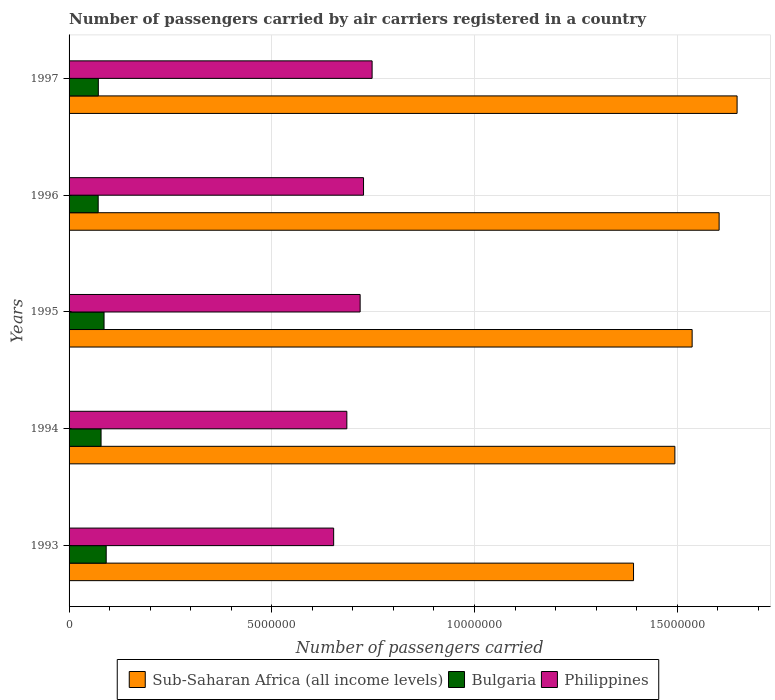How many groups of bars are there?
Provide a succinct answer. 5. Are the number of bars per tick equal to the number of legend labels?
Your answer should be very brief. Yes. How many bars are there on the 2nd tick from the top?
Offer a terse response. 3. What is the number of passengers carried by air carriers in Sub-Saharan Africa (all income levels) in 1997?
Give a very brief answer. 1.65e+07. Across all years, what is the maximum number of passengers carried by air carriers in Bulgaria?
Make the answer very short. 9.16e+05. Across all years, what is the minimum number of passengers carried by air carriers in Philippines?
Your response must be concise. 6.53e+06. What is the total number of passengers carried by air carriers in Bulgaria in the graph?
Offer a very short reply. 4.01e+06. What is the difference between the number of passengers carried by air carriers in Sub-Saharan Africa (all income levels) in 1994 and that in 1997?
Your response must be concise. -1.53e+06. What is the difference between the number of passengers carried by air carriers in Bulgaria in 1993 and the number of passengers carried by air carriers in Philippines in 1997?
Your answer should be compact. -6.56e+06. What is the average number of passengers carried by air carriers in Bulgaria per year?
Ensure brevity in your answer.  8.02e+05. In the year 1995, what is the difference between the number of passengers carried by air carriers in Bulgaria and number of passengers carried by air carriers in Sub-Saharan Africa (all income levels)?
Give a very brief answer. -1.45e+07. What is the ratio of the number of passengers carried by air carriers in Bulgaria in 1993 to that in 1995?
Provide a succinct answer. 1.06. What is the difference between the highest and the second highest number of passengers carried by air carriers in Philippines?
Your answer should be very brief. 2.12e+05. What is the difference between the highest and the lowest number of passengers carried by air carriers in Philippines?
Make the answer very short. 9.48e+05. In how many years, is the number of passengers carried by air carriers in Sub-Saharan Africa (all income levels) greater than the average number of passengers carried by air carriers in Sub-Saharan Africa (all income levels) taken over all years?
Your answer should be compact. 3. Is the sum of the number of passengers carried by air carriers in Bulgaria in 1994 and 1995 greater than the maximum number of passengers carried by air carriers in Sub-Saharan Africa (all income levels) across all years?
Your response must be concise. No. What does the 2nd bar from the top in 1994 represents?
Your response must be concise. Bulgaria. What does the 3rd bar from the bottom in 1996 represents?
Ensure brevity in your answer.  Philippines. How many bars are there?
Give a very brief answer. 15. What is the difference between two consecutive major ticks on the X-axis?
Keep it short and to the point. 5.00e+06. Does the graph contain any zero values?
Keep it short and to the point. No. Does the graph contain grids?
Your response must be concise. Yes. Where does the legend appear in the graph?
Make the answer very short. Bottom center. How many legend labels are there?
Your answer should be compact. 3. How are the legend labels stacked?
Your answer should be compact. Horizontal. What is the title of the graph?
Offer a terse response. Number of passengers carried by air carriers registered in a country. Does "Middle East & North Africa (developing only)" appear as one of the legend labels in the graph?
Keep it short and to the point. No. What is the label or title of the X-axis?
Ensure brevity in your answer.  Number of passengers carried. What is the label or title of the Y-axis?
Give a very brief answer. Years. What is the Number of passengers carried in Sub-Saharan Africa (all income levels) in 1993?
Offer a very short reply. 1.39e+07. What is the Number of passengers carried of Bulgaria in 1993?
Make the answer very short. 9.16e+05. What is the Number of passengers carried in Philippines in 1993?
Offer a terse response. 6.53e+06. What is the Number of passengers carried in Sub-Saharan Africa (all income levels) in 1994?
Give a very brief answer. 1.49e+07. What is the Number of passengers carried of Bulgaria in 1994?
Keep it short and to the point. 7.89e+05. What is the Number of passengers carried in Philippines in 1994?
Provide a succinct answer. 6.85e+06. What is the Number of passengers carried of Sub-Saharan Africa (all income levels) in 1995?
Provide a short and direct response. 1.54e+07. What is the Number of passengers carried in Bulgaria in 1995?
Your answer should be very brief. 8.63e+05. What is the Number of passengers carried of Philippines in 1995?
Provide a succinct answer. 7.18e+06. What is the Number of passengers carried in Sub-Saharan Africa (all income levels) in 1996?
Provide a succinct answer. 1.60e+07. What is the Number of passengers carried of Bulgaria in 1996?
Make the answer very short. 7.18e+05. What is the Number of passengers carried of Philippines in 1996?
Offer a very short reply. 7.26e+06. What is the Number of passengers carried of Sub-Saharan Africa (all income levels) in 1997?
Offer a terse response. 1.65e+07. What is the Number of passengers carried in Bulgaria in 1997?
Give a very brief answer. 7.22e+05. What is the Number of passengers carried in Philippines in 1997?
Offer a terse response. 7.47e+06. Across all years, what is the maximum Number of passengers carried of Sub-Saharan Africa (all income levels)?
Provide a succinct answer. 1.65e+07. Across all years, what is the maximum Number of passengers carried in Bulgaria?
Keep it short and to the point. 9.16e+05. Across all years, what is the maximum Number of passengers carried of Philippines?
Your response must be concise. 7.47e+06. Across all years, what is the minimum Number of passengers carried in Sub-Saharan Africa (all income levels)?
Give a very brief answer. 1.39e+07. Across all years, what is the minimum Number of passengers carried of Bulgaria?
Your response must be concise. 7.18e+05. Across all years, what is the minimum Number of passengers carried in Philippines?
Provide a succinct answer. 6.53e+06. What is the total Number of passengers carried of Sub-Saharan Africa (all income levels) in the graph?
Keep it short and to the point. 7.67e+07. What is the total Number of passengers carried of Bulgaria in the graph?
Provide a short and direct response. 4.01e+06. What is the total Number of passengers carried in Philippines in the graph?
Offer a very short reply. 3.53e+07. What is the difference between the Number of passengers carried of Sub-Saharan Africa (all income levels) in 1993 and that in 1994?
Your response must be concise. -1.02e+06. What is the difference between the Number of passengers carried of Bulgaria in 1993 and that in 1994?
Keep it short and to the point. 1.27e+05. What is the difference between the Number of passengers carried in Philippines in 1993 and that in 1994?
Ensure brevity in your answer.  -3.25e+05. What is the difference between the Number of passengers carried in Sub-Saharan Africa (all income levels) in 1993 and that in 1995?
Make the answer very short. -1.45e+06. What is the difference between the Number of passengers carried of Bulgaria in 1993 and that in 1995?
Provide a short and direct response. 5.31e+04. What is the difference between the Number of passengers carried in Philippines in 1993 and that in 1995?
Your response must be concise. -6.53e+05. What is the difference between the Number of passengers carried of Sub-Saharan Africa (all income levels) in 1993 and that in 1996?
Offer a very short reply. -2.11e+06. What is the difference between the Number of passengers carried of Bulgaria in 1993 and that in 1996?
Provide a succinct answer. 1.98e+05. What is the difference between the Number of passengers carried of Philippines in 1993 and that in 1996?
Make the answer very short. -7.37e+05. What is the difference between the Number of passengers carried in Sub-Saharan Africa (all income levels) in 1993 and that in 1997?
Offer a very short reply. -2.55e+06. What is the difference between the Number of passengers carried of Bulgaria in 1993 and that in 1997?
Give a very brief answer. 1.94e+05. What is the difference between the Number of passengers carried of Philippines in 1993 and that in 1997?
Keep it short and to the point. -9.48e+05. What is the difference between the Number of passengers carried in Sub-Saharan Africa (all income levels) in 1994 and that in 1995?
Give a very brief answer. -4.26e+05. What is the difference between the Number of passengers carried of Bulgaria in 1994 and that in 1995?
Provide a short and direct response. -7.35e+04. What is the difference between the Number of passengers carried in Philippines in 1994 and that in 1995?
Give a very brief answer. -3.28e+05. What is the difference between the Number of passengers carried in Sub-Saharan Africa (all income levels) in 1994 and that in 1996?
Provide a short and direct response. -1.09e+06. What is the difference between the Number of passengers carried in Bulgaria in 1994 and that in 1996?
Make the answer very short. 7.10e+04. What is the difference between the Number of passengers carried of Philippines in 1994 and that in 1996?
Keep it short and to the point. -4.12e+05. What is the difference between the Number of passengers carried of Sub-Saharan Africa (all income levels) in 1994 and that in 1997?
Offer a terse response. -1.53e+06. What is the difference between the Number of passengers carried in Bulgaria in 1994 and that in 1997?
Provide a succinct answer. 6.75e+04. What is the difference between the Number of passengers carried in Philippines in 1994 and that in 1997?
Offer a very short reply. -6.23e+05. What is the difference between the Number of passengers carried of Sub-Saharan Africa (all income levels) in 1995 and that in 1996?
Offer a terse response. -6.66e+05. What is the difference between the Number of passengers carried in Bulgaria in 1995 and that in 1996?
Ensure brevity in your answer.  1.44e+05. What is the difference between the Number of passengers carried of Philippines in 1995 and that in 1996?
Provide a short and direct response. -8.35e+04. What is the difference between the Number of passengers carried of Sub-Saharan Africa (all income levels) in 1995 and that in 1997?
Provide a succinct answer. -1.11e+06. What is the difference between the Number of passengers carried in Bulgaria in 1995 and that in 1997?
Ensure brevity in your answer.  1.41e+05. What is the difference between the Number of passengers carried of Philippines in 1995 and that in 1997?
Provide a succinct answer. -2.95e+05. What is the difference between the Number of passengers carried of Sub-Saharan Africa (all income levels) in 1996 and that in 1997?
Ensure brevity in your answer.  -4.43e+05. What is the difference between the Number of passengers carried in Bulgaria in 1996 and that in 1997?
Your response must be concise. -3500. What is the difference between the Number of passengers carried of Philippines in 1996 and that in 1997?
Offer a terse response. -2.12e+05. What is the difference between the Number of passengers carried in Sub-Saharan Africa (all income levels) in 1993 and the Number of passengers carried in Bulgaria in 1994?
Make the answer very short. 1.31e+07. What is the difference between the Number of passengers carried in Sub-Saharan Africa (all income levels) in 1993 and the Number of passengers carried in Philippines in 1994?
Offer a terse response. 7.07e+06. What is the difference between the Number of passengers carried in Bulgaria in 1993 and the Number of passengers carried in Philippines in 1994?
Your answer should be very brief. -5.94e+06. What is the difference between the Number of passengers carried in Sub-Saharan Africa (all income levels) in 1993 and the Number of passengers carried in Bulgaria in 1995?
Provide a succinct answer. 1.31e+07. What is the difference between the Number of passengers carried of Sub-Saharan Africa (all income levels) in 1993 and the Number of passengers carried of Philippines in 1995?
Offer a very short reply. 6.74e+06. What is the difference between the Number of passengers carried in Bulgaria in 1993 and the Number of passengers carried in Philippines in 1995?
Give a very brief answer. -6.26e+06. What is the difference between the Number of passengers carried of Sub-Saharan Africa (all income levels) in 1993 and the Number of passengers carried of Bulgaria in 1996?
Keep it short and to the point. 1.32e+07. What is the difference between the Number of passengers carried of Sub-Saharan Africa (all income levels) in 1993 and the Number of passengers carried of Philippines in 1996?
Offer a very short reply. 6.66e+06. What is the difference between the Number of passengers carried of Bulgaria in 1993 and the Number of passengers carried of Philippines in 1996?
Provide a succinct answer. -6.35e+06. What is the difference between the Number of passengers carried of Sub-Saharan Africa (all income levels) in 1993 and the Number of passengers carried of Bulgaria in 1997?
Ensure brevity in your answer.  1.32e+07. What is the difference between the Number of passengers carried of Sub-Saharan Africa (all income levels) in 1993 and the Number of passengers carried of Philippines in 1997?
Your answer should be compact. 6.45e+06. What is the difference between the Number of passengers carried of Bulgaria in 1993 and the Number of passengers carried of Philippines in 1997?
Provide a short and direct response. -6.56e+06. What is the difference between the Number of passengers carried of Sub-Saharan Africa (all income levels) in 1994 and the Number of passengers carried of Bulgaria in 1995?
Ensure brevity in your answer.  1.41e+07. What is the difference between the Number of passengers carried of Sub-Saharan Africa (all income levels) in 1994 and the Number of passengers carried of Philippines in 1995?
Offer a terse response. 7.76e+06. What is the difference between the Number of passengers carried in Bulgaria in 1994 and the Number of passengers carried in Philippines in 1995?
Offer a very short reply. -6.39e+06. What is the difference between the Number of passengers carried of Sub-Saharan Africa (all income levels) in 1994 and the Number of passengers carried of Bulgaria in 1996?
Ensure brevity in your answer.  1.42e+07. What is the difference between the Number of passengers carried of Sub-Saharan Africa (all income levels) in 1994 and the Number of passengers carried of Philippines in 1996?
Keep it short and to the point. 7.68e+06. What is the difference between the Number of passengers carried in Bulgaria in 1994 and the Number of passengers carried in Philippines in 1996?
Provide a short and direct response. -6.47e+06. What is the difference between the Number of passengers carried in Sub-Saharan Africa (all income levels) in 1994 and the Number of passengers carried in Bulgaria in 1997?
Make the answer very short. 1.42e+07. What is the difference between the Number of passengers carried in Sub-Saharan Africa (all income levels) in 1994 and the Number of passengers carried in Philippines in 1997?
Your response must be concise. 7.47e+06. What is the difference between the Number of passengers carried in Bulgaria in 1994 and the Number of passengers carried in Philippines in 1997?
Offer a very short reply. -6.69e+06. What is the difference between the Number of passengers carried of Sub-Saharan Africa (all income levels) in 1995 and the Number of passengers carried of Bulgaria in 1996?
Ensure brevity in your answer.  1.47e+07. What is the difference between the Number of passengers carried of Sub-Saharan Africa (all income levels) in 1995 and the Number of passengers carried of Philippines in 1996?
Offer a terse response. 8.11e+06. What is the difference between the Number of passengers carried in Bulgaria in 1995 and the Number of passengers carried in Philippines in 1996?
Your response must be concise. -6.40e+06. What is the difference between the Number of passengers carried of Sub-Saharan Africa (all income levels) in 1995 and the Number of passengers carried of Bulgaria in 1997?
Offer a very short reply. 1.46e+07. What is the difference between the Number of passengers carried in Sub-Saharan Africa (all income levels) in 1995 and the Number of passengers carried in Philippines in 1997?
Your answer should be compact. 7.89e+06. What is the difference between the Number of passengers carried of Bulgaria in 1995 and the Number of passengers carried of Philippines in 1997?
Offer a terse response. -6.61e+06. What is the difference between the Number of passengers carried in Sub-Saharan Africa (all income levels) in 1996 and the Number of passengers carried in Bulgaria in 1997?
Make the answer very short. 1.53e+07. What is the difference between the Number of passengers carried of Sub-Saharan Africa (all income levels) in 1996 and the Number of passengers carried of Philippines in 1997?
Your answer should be very brief. 8.56e+06. What is the difference between the Number of passengers carried in Bulgaria in 1996 and the Number of passengers carried in Philippines in 1997?
Offer a very short reply. -6.76e+06. What is the average Number of passengers carried of Sub-Saharan Africa (all income levels) per year?
Provide a short and direct response. 1.53e+07. What is the average Number of passengers carried of Bulgaria per year?
Provide a succinct answer. 8.02e+05. What is the average Number of passengers carried of Philippines per year?
Offer a very short reply. 7.06e+06. In the year 1993, what is the difference between the Number of passengers carried of Sub-Saharan Africa (all income levels) and Number of passengers carried of Bulgaria?
Offer a very short reply. 1.30e+07. In the year 1993, what is the difference between the Number of passengers carried of Sub-Saharan Africa (all income levels) and Number of passengers carried of Philippines?
Give a very brief answer. 7.40e+06. In the year 1993, what is the difference between the Number of passengers carried of Bulgaria and Number of passengers carried of Philippines?
Keep it short and to the point. -5.61e+06. In the year 1994, what is the difference between the Number of passengers carried of Sub-Saharan Africa (all income levels) and Number of passengers carried of Bulgaria?
Your answer should be very brief. 1.42e+07. In the year 1994, what is the difference between the Number of passengers carried of Sub-Saharan Africa (all income levels) and Number of passengers carried of Philippines?
Provide a succinct answer. 8.09e+06. In the year 1994, what is the difference between the Number of passengers carried of Bulgaria and Number of passengers carried of Philippines?
Your answer should be very brief. -6.06e+06. In the year 1995, what is the difference between the Number of passengers carried in Sub-Saharan Africa (all income levels) and Number of passengers carried in Bulgaria?
Offer a terse response. 1.45e+07. In the year 1995, what is the difference between the Number of passengers carried of Sub-Saharan Africa (all income levels) and Number of passengers carried of Philippines?
Offer a terse response. 8.19e+06. In the year 1995, what is the difference between the Number of passengers carried in Bulgaria and Number of passengers carried in Philippines?
Offer a terse response. -6.32e+06. In the year 1996, what is the difference between the Number of passengers carried of Sub-Saharan Africa (all income levels) and Number of passengers carried of Bulgaria?
Your answer should be very brief. 1.53e+07. In the year 1996, what is the difference between the Number of passengers carried of Sub-Saharan Africa (all income levels) and Number of passengers carried of Philippines?
Keep it short and to the point. 8.77e+06. In the year 1996, what is the difference between the Number of passengers carried of Bulgaria and Number of passengers carried of Philippines?
Make the answer very short. -6.54e+06. In the year 1997, what is the difference between the Number of passengers carried of Sub-Saharan Africa (all income levels) and Number of passengers carried of Bulgaria?
Offer a very short reply. 1.58e+07. In the year 1997, what is the difference between the Number of passengers carried of Sub-Saharan Africa (all income levels) and Number of passengers carried of Philippines?
Keep it short and to the point. 9.00e+06. In the year 1997, what is the difference between the Number of passengers carried of Bulgaria and Number of passengers carried of Philippines?
Offer a terse response. -6.75e+06. What is the ratio of the Number of passengers carried of Sub-Saharan Africa (all income levels) in 1993 to that in 1994?
Offer a terse response. 0.93. What is the ratio of the Number of passengers carried of Bulgaria in 1993 to that in 1994?
Ensure brevity in your answer.  1.16. What is the ratio of the Number of passengers carried of Philippines in 1993 to that in 1994?
Your answer should be very brief. 0.95. What is the ratio of the Number of passengers carried in Sub-Saharan Africa (all income levels) in 1993 to that in 1995?
Your answer should be compact. 0.91. What is the ratio of the Number of passengers carried of Bulgaria in 1993 to that in 1995?
Make the answer very short. 1.06. What is the ratio of the Number of passengers carried of Philippines in 1993 to that in 1995?
Give a very brief answer. 0.91. What is the ratio of the Number of passengers carried in Sub-Saharan Africa (all income levels) in 1993 to that in 1996?
Your answer should be compact. 0.87. What is the ratio of the Number of passengers carried in Bulgaria in 1993 to that in 1996?
Your answer should be very brief. 1.28. What is the ratio of the Number of passengers carried in Philippines in 1993 to that in 1996?
Give a very brief answer. 0.9. What is the ratio of the Number of passengers carried of Sub-Saharan Africa (all income levels) in 1993 to that in 1997?
Offer a terse response. 0.84. What is the ratio of the Number of passengers carried of Bulgaria in 1993 to that in 1997?
Provide a succinct answer. 1.27. What is the ratio of the Number of passengers carried in Philippines in 1993 to that in 1997?
Your answer should be very brief. 0.87. What is the ratio of the Number of passengers carried in Sub-Saharan Africa (all income levels) in 1994 to that in 1995?
Your response must be concise. 0.97. What is the ratio of the Number of passengers carried of Bulgaria in 1994 to that in 1995?
Offer a very short reply. 0.91. What is the ratio of the Number of passengers carried of Philippines in 1994 to that in 1995?
Make the answer very short. 0.95. What is the ratio of the Number of passengers carried in Sub-Saharan Africa (all income levels) in 1994 to that in 1996?
Ensure brevity in your answer.  0.93. What is the ratio of the Number of passengers carried in Bulgaria in 1994 to that in 1996?
Your response must be concise. 1.1. What is the ratio of the Number of passengers carried in Philippines in 1994 to that in 1996?
Make the answer very short. 0.94. What is the ratio of the Number of passengers carried in Sub-Saharan Africa (all income levels) in 1994 to that in 1997?
Ensure brevity in your answer.  0.91. What is the ratio of the Number of passengers carried of Bulgaria in 1994 to that in 1997?
Your response must be concise. 1.09. What is the ratio of the Number of passengers carried in Philippines in 1994 to that in 1997?
Provide a succinct answer. 0.92. What is the ratio of the Number of passengers carried in Sub-Saharan Africa (all income levels) in 1995 to that in 1996?
Your response must be concise. 0.96. What is the ratio of the Number of passengers carried of Bulgaria in 1995 to that in 1996?
Your response must be concise. 1.2. What is the ratio of the Number of passengers carried in Sub-Saharan Africa (all income levels) in 1995 to that in 1997?
Provide a short and direct response. 0.93. What is the ratio of the Number of passengers carried in Bulgaria in 1995 to that in 1997?
Offer a terse response. 1.2. What is the ratio of the Number of passengers carried of Philippines in 1995 to that in 1997?
Provide a succinct answer. 0.96. What is the ratio of the Number of passengers carried of Sub-Saharan Africa (all income levels) in 1996 to that in 1997?
Offer a terse response. 0.97. What is the ratio of the Number of passengers carried of Bulgaria in 1996 to that in 1997?
Your answer should be compact. 1. What is the ratio of the Number of passengers carried of Philippines in 1996 to that in 1997?
Provide a succinct answer. 0.97. What is the difference between the highest and the second highest Number of passengers carried of Sub-Saharan Africa (all income levels)?
Provide a short and direct response. 4.43e+05. What is the difference between the highest and the second highest Number of passengers carried in Bulgaria?
Offer a very short reply. 5.31e+04. What is the difference between the highest and the second highest Number of passengers carried in Philippines?
Your response must be concise. 2.12e+05. What is the difference between the highest and the lowest Number of passengers carried of Sub-Saharan Africa (all income levels)?
Your answer should be compact. 2.55e+06. What is the difference between the highest and the lowest Number of passengers carried of Bulgaria?
Make the answer very short. 1.98e+05. What is the difference between the highest and the lowest Number of passengers carried of Philippines?
Offer a terse response. 9.48e+05. 